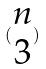<formula> <loc_0><loc_0><loc_500><loc_500>( \begin{matrix} n \\ 3 \end{matrix} )</formula> 